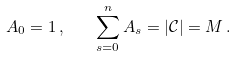Convert formula to latex. <formula><loc_0><loc_0><loc_500><loc_500>A _ { 0 } = 1 \, , \quad \sum _ { s = 0 } ^ { n } A _ { s } = | \mathcal { C } | = M \, .</formula> 